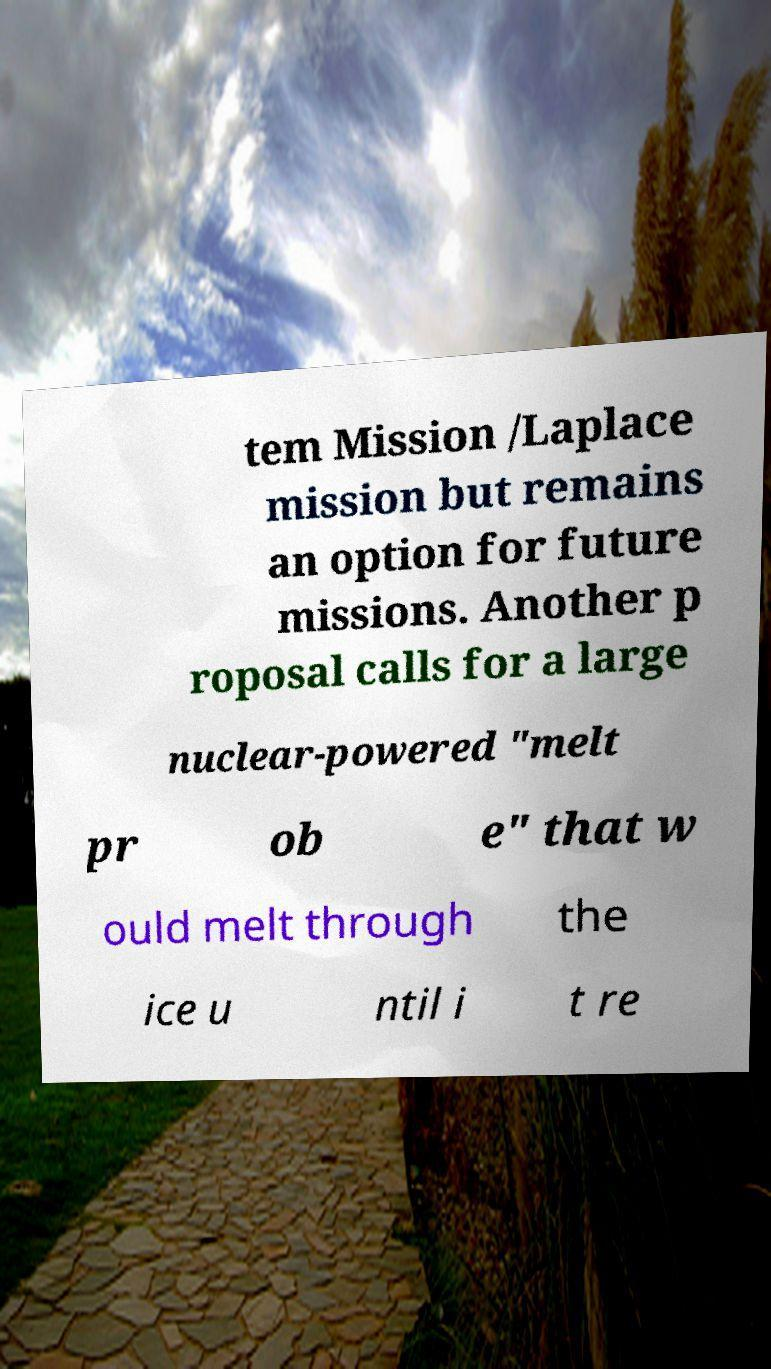Please read and relay the text visible in this image. What does it say? tem Mission /Laplace mission but remains an option for future missions. Another p roposal calls for a large nuclear-powered "melt pr ob e" that w ould melt through the ice u ntil i t re 